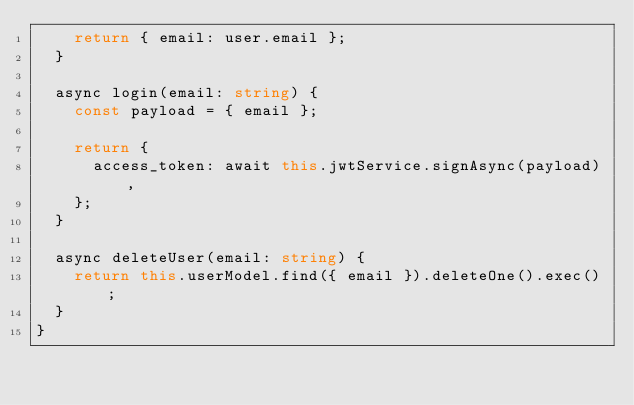Convert code to text. <code><loc_0><loc_0><loc_500><loc_500><_TypeScript_>    return { email: user.email };
  }

  async login(email: string) {
    const payload = { email };

    return {
      access_token: await this.jwtService.signAsync(payload),
    };
  }

  async deleteUser(email: string) {
    return this.userModel.find({ email }).deleteOne().exec();
  }
}
</code> 